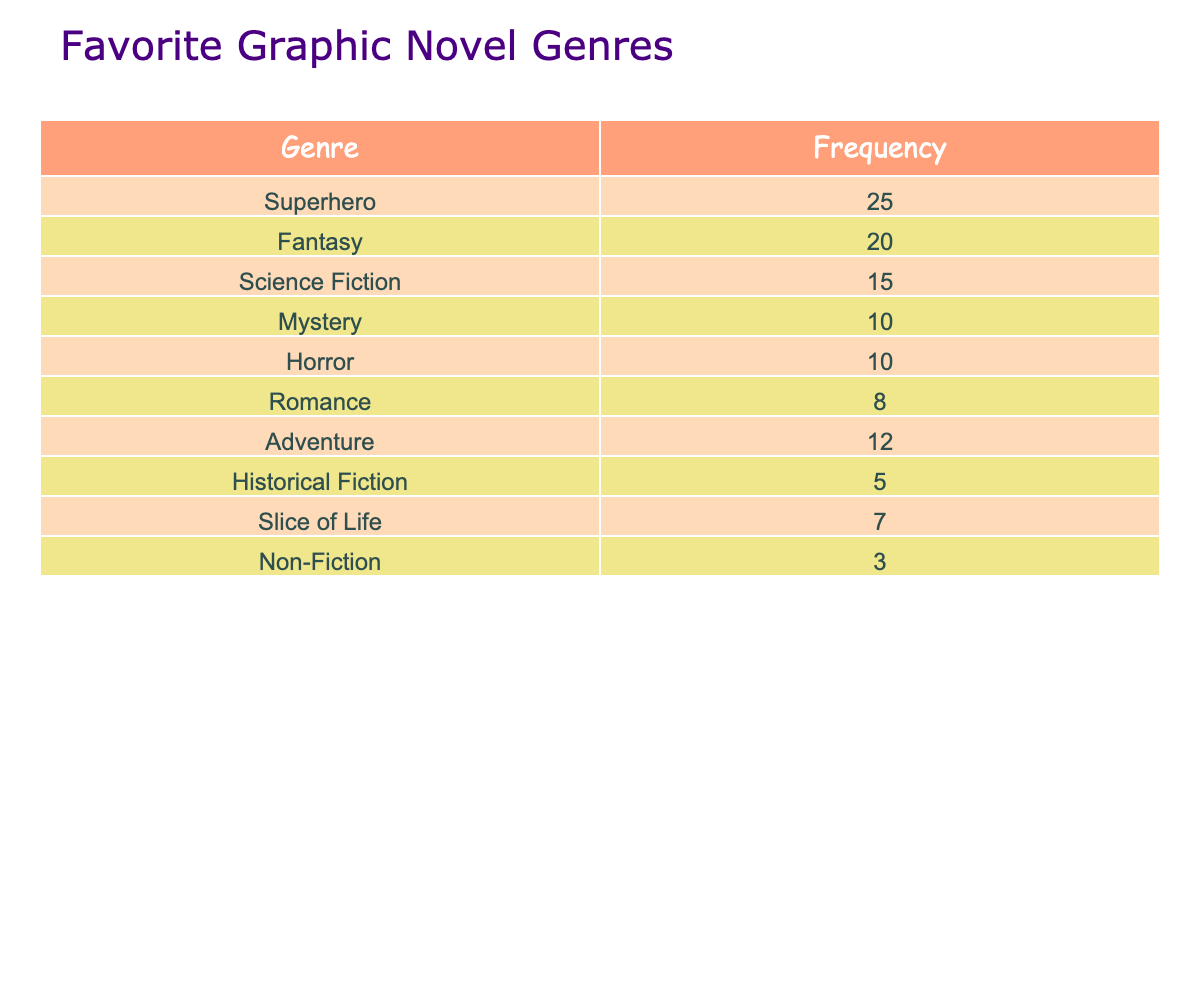What is the most popular graphic novel genre among teenagers according to the table? The genre with the highest frequency value in the table is "Superhero," which has a frequency of 25. Therefore, it is the most popular genre.
Answer: Superhero How many teenagers read fantasy graphic novels? The frequency value for the "Fantasy" genre is 20, indicating that 20 teenagers read fantasy graphic novels.
Answer: 20 Is there a genre that at least 10 teenagers prefer? The genres "Superhero," "Fantasy," "Science Fiction," "Adventure," "Mystery," and "Horror" have frequencies of 25, 20, 15, 12, 10, and 10, respectively, all of which are at least 10.
Answer: Yes What is the total number of teenagers who read graphic novels in this survey? To find the total, add up all the frequencies: 25 + 20 + 15 + 10 + 10 + 8 + 12 + 5 + 7 + 3 = 115. Thus, a total of 115 teenagers read graphic novels.
Answer: 115 Which genre has the lowest popularity based on the data? The genre with the lowest frequency is "Non-Fiction," having a frequency of just 3. This indicates it is the least popular among the teens surveyed.
Answer: Non-Fiction What is the difference in frequency between the most and least popular genre? The most popular genre is "Superhero" with a frequency of 25 while the least popular is "Non-Fiction" with 3. The difference is 25 - 3 = 22.
Answer: 22 What is the average number of readers for the genres that have a frequency of 10 or higher? The genres with a frequency of 10 or higher are "Superhero," "Fantasy," "Science Fiction," "Adventure," "Mystery," and "Horror." The total frequency for these is 25 + 20 + 15 + 12 + 10 + 10 = 102. There are 6 genres, so the average is 102 / 6 = 17.
Answer: 17 Are there more readers for adventure novels or romance novels? "Adventure" has a frequency of 12, while "Romance" has a frequency of 8. Since 12 is greater than 8, there are more readers for adventure novels.
Answer: Adventure novels How many genres have fewer readers than 10? The genres with fewer than 10 readers are "Romance" (8), "Historical Fiction" (5), and "Non-Fiction" (3). This counts as 3 genres in total.
Answer: 3 